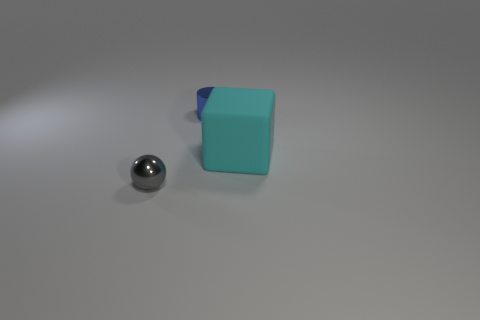There is another thing that is the same material as the gray thing; what shape is it?
Your response must be concise. Cylinder. How many things are to the left of the cyan matte thing and in front of the small cylinder?
Make the answer very short. 1. There is a tiny gray metal object; are there any tiny blue objects to the right of it?
Make the answer very short. Yes. What number of things are either brown objects or small things on the left side of the small blue thing?
Offer a very short reply. 1. What number of other objects are the same shape as the rubber object?
Make the answer very short. 0. Is the object that is in front of the large thing made of the same material as the big thing?
Ensure brevity in your answer.  No. What number of objects are large red metallic cubes or tiny metallic things?
Offer a very short reply. 2. What is the size of the gray ball?
Your response must be concise. Small. Are there more metal things behind the big thing than tiny green spheres?
Give a very brief answer. Yes. Are there any other things that have the same material as the large cyan cube?
Give a very brief answer. No. 